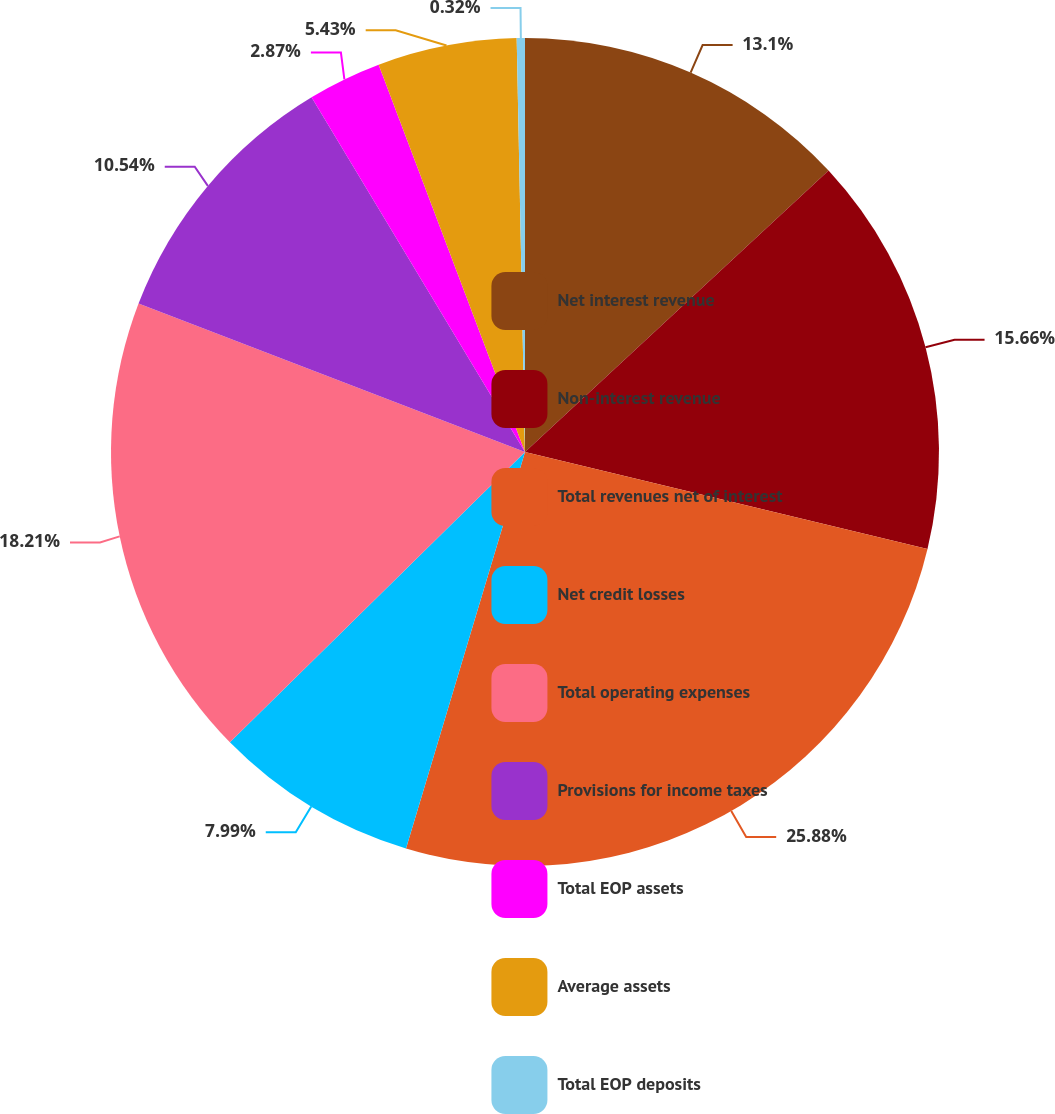<chart> <loc_0><loc_0><loc_500><loc_500><pie_chart><fcel>Net interest revenue<fcel>Non-interest revenue<fcel>Total revenues net of interest<fcel>Net credit losses<fcel>Total operating expenses<fcel>Provisions for income taxes<fcel>Total EOP assets<fcel>Average assets<fcel>Total EOP deposits<nl><fcel>13.1%<fcel>15.66%<fcel>25.88%<fcel>7.99%<fcel>18.21%<fcel>10.54%<fcel>2.87%<fcel>5.43%<fcel>0.32%<nl></chart> 